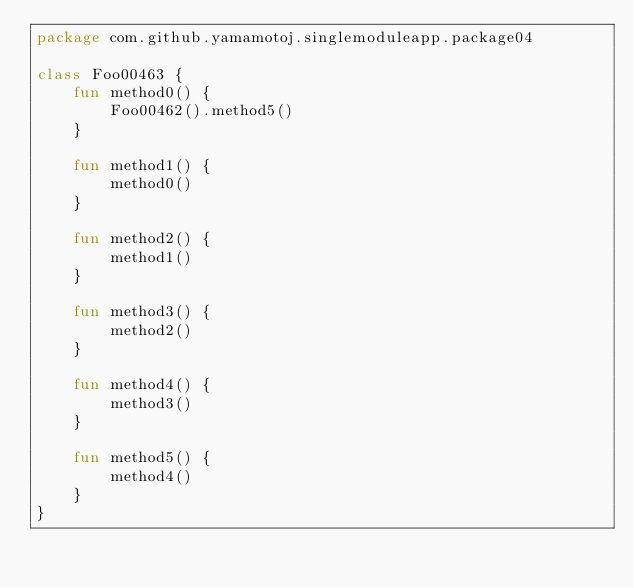Convert code to text. <code><loc_0><loc_0><loc_500><loc_500><_Kotlin_>package com.github.yamamotoj.singlemoduleapp.package04

class Foo00463 {
    fun method0() {
        Foo00462().method5()
    }

    fun method1() {
        method0()
    }

    fun method2() {
        method1()
    }

    fun method3() {
        method2()
    }

    fun method4() {
        method3()
    }

    fun method5() {
        method4()
    }
}
</code> 